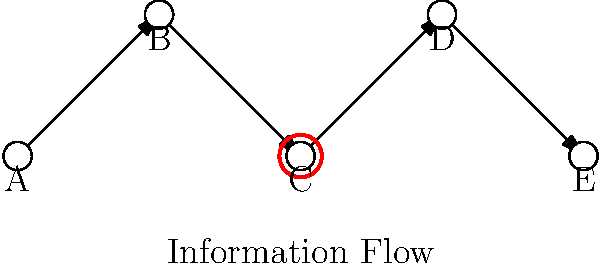In the network diagram above, node C represents a bottleneck in the flow of ethical information. As an ethics professor who prioritizes human judgment and empathy, how might this bottleneck affect the ethical decision-making process, and what human-centered approach would you suggest to mitigate its impact? To answer this question, we need to consider the following steps:

1. Understand the bottleneck: Node C represents a point in the network where information flow is restricted, potentially limiting the spread of ethical considerations.

2. Impact on ethical decision-making:
   a) Reduced information availability: Decision-makers at nodes D and E may not have access to all relevant ethical perspectives.
   b) Delayed response: Time-sensitive ethical issues may not be addressed promptly.
   c) Potential for bias: The bottleneck might filter or distort information, leading to skewed ethical judgments.

3. Human judgment and empathy considerations:
   a) Recognize that computational models alone cannot fully address the complexity of ethical decision-making.
   b) Understand that human interpretation and contextualization of information are crucial for ethical reasoning.

4. Human-centered approach to mitigate the impact:
   a) Promote direct human communication: Encourage face-to-face or video conversations to bypass the bottleneck.
   b) Establish ethical committees: Create diverse groups to discuss and disseminate ethical considerations.
   c) Implement ethical training: Ensure all network participants have a strong foundation in ethical reasoning.
   d) Encourage empathy exercises: Help decision-makers understand multiple perspectives.
   e) Develop alternative communication channels: Create backup routes for critical ethical information.

5. Emphasize the importance of human judgment:
   a) Stress that while the network structure is important, human interpretation and application of ethical principles are paramount.
   b) Encourage critical thinking and questioning of information, regardless of its source in the network.

By applying these human-centered approaches, we can mitigate the impact of the bottleneck while prioritizing human judgment and empathy in ethical decision-making.
Answer: Implement human-centered communication strategies and ethical training to bypass the bottleneck, while emphasizing critical thinking and empathy in decision-making. 